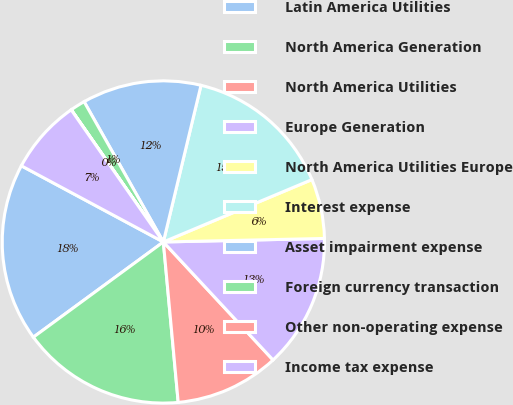Convert chart. <chart><loc_0><loc_0><loc_500><loc_500><pie_chart><fcel>Latin America Utilities<fcel>North America Generation<fcel>North America Utilities<fcel>Europe Generation<fcel>North America Utilities Europe<fcel>Interest expense<fcel>Asset impairment expense<fcel>Foreign currency transaction<fcel>Other non-operating expense<fcel>Income tax expense<nl><fcel>17.9%<fcel>16.41%<fcel>10.45%<fcel>13.43%<fcel>5.98%<fcel>14.92%<fcel>11.94%<fcel>1.5%<fcel>0.01%<fcel>7.47%<nl></chart> 